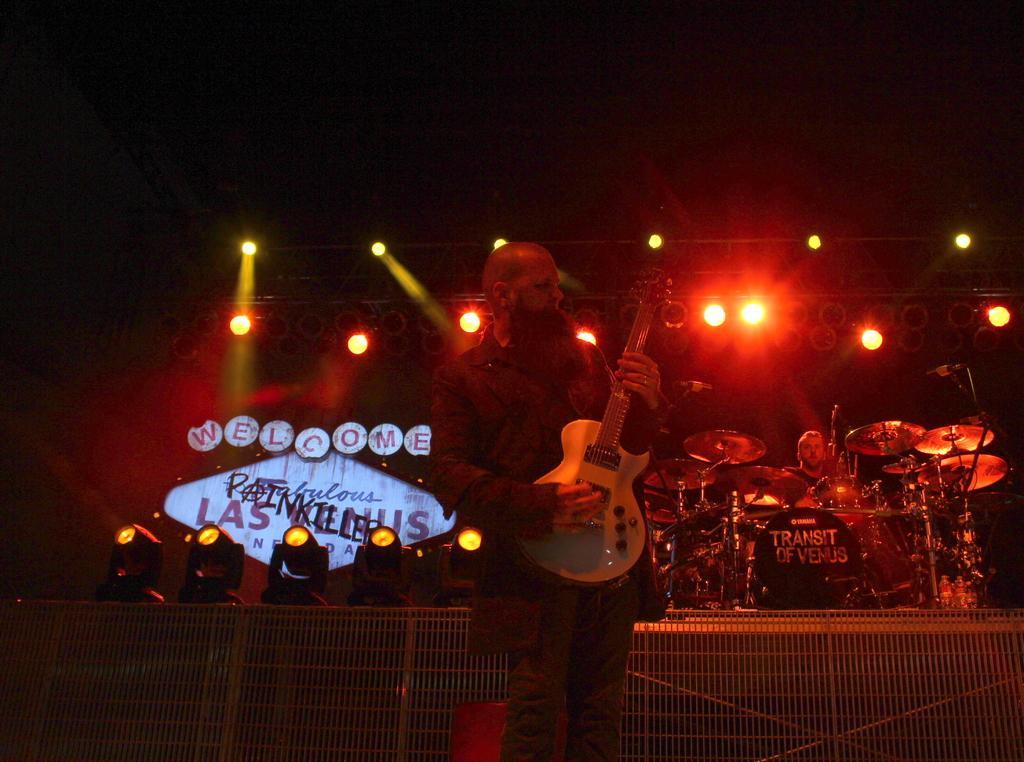In one or two sentences, can you explain what this image depicts? In the foreground, a person is standing and playing a guitar. In the right, a person is sitting and playing musical instruments. In the middle lights are visible of yellow and red in color. In the left, a board is there and lights are visible. At the bottom fence is there. The background is dark in color. It looks as if the image is taken on the stage during night time. 